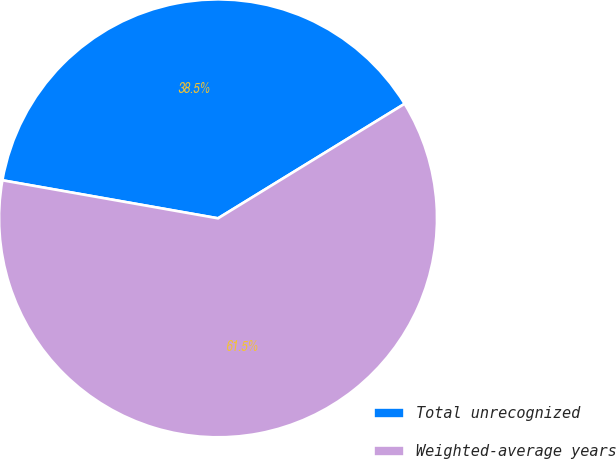Convert chart. <chart><loc_0><loc_0><loc_500><loc_500><pie_chart><fcel>Total unrecognized<fcel>Weighted-average years<nl><fcel>38.46%<fcel>61.54%<nl></chart> 